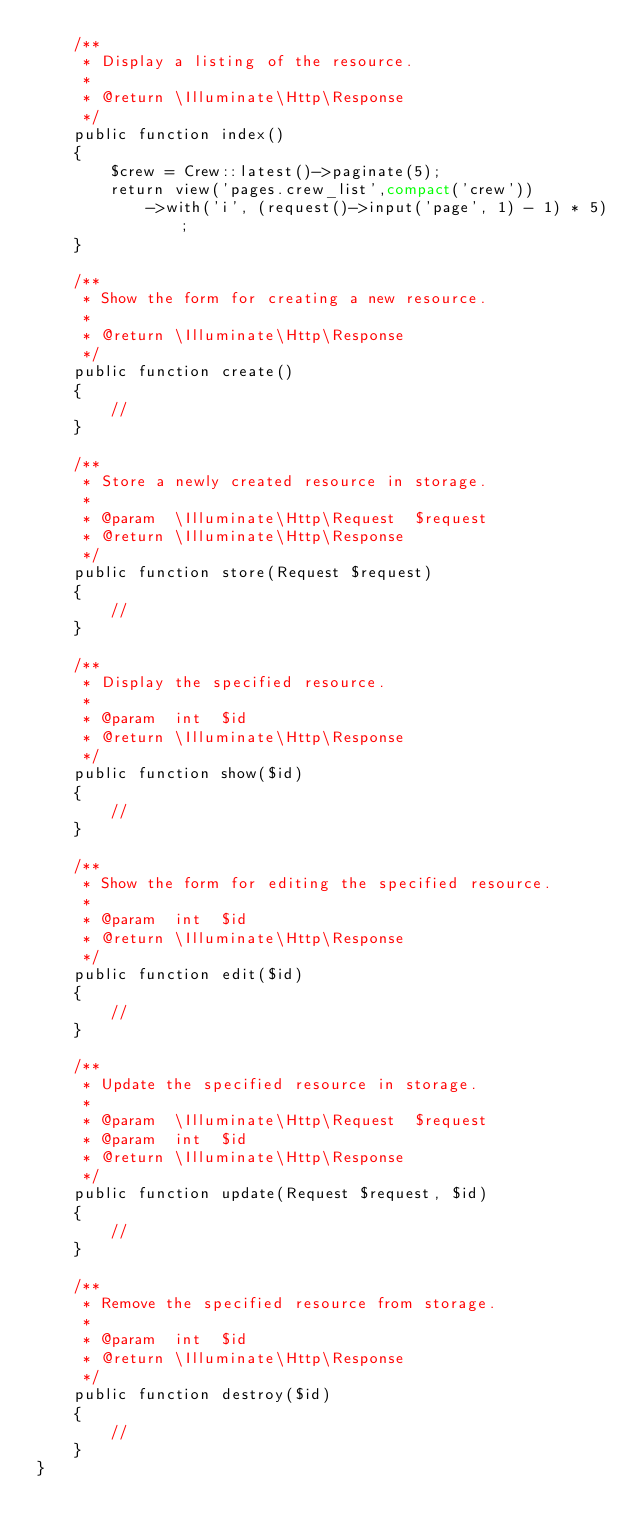<code> <loc_0><loc_0><loc_500><loc_500><_PHP_>    /**
     * Display a listing of the resource.
     *
     * @return \Illuminate\Http\Response
     */
    public function index()
    {
        $crew = Crew::latest()->paginate(5);
        return view('pages.crew_list',compact('crew'))
            ->with('i', (request()->input('page', 1) - 1) * 5);
    }

    /**
     * Show the form for creating a new resource.
     *
     * @return \Illuminate\Http\Response
     */
    public function create()
    {
        //
    }

    /**
     * Store a newly created resource in storage.
     *
     * @param  \Illuminate\Http\Request  $request
     * @return \Illuminate\Http\Response
     */
    public function store(Request $request)
    {
        //
    }

    /**
     * Display the specified resource.
     *
     * @param  int  $id
     * @return \Illuminate\Http\Response
     */
    public function show($id)
    {
        //
    }

    /**
     * Show the form for editing the specified resource.
     *
     * @param  int  $id
     * @return \Illuminate\Http\Response
     */
    public function edit($id)
    {
        //
    }

    /**
     * Update the specified resource in storage.
     *
     * @param  \Illuminate\Http\Request  $request
     * @param  int  $id
     * @return \Illuminate\Http\Response
     */
    public function update(Request $request, $id)
    {
        //
    }

    /**
     * Remove the specified resource from storage.
     *
     * @param  int  $id
     * @return \Illuminate\Http\Response
     */
    public function destroy($id)
    {
        //
    }
}
</code> 